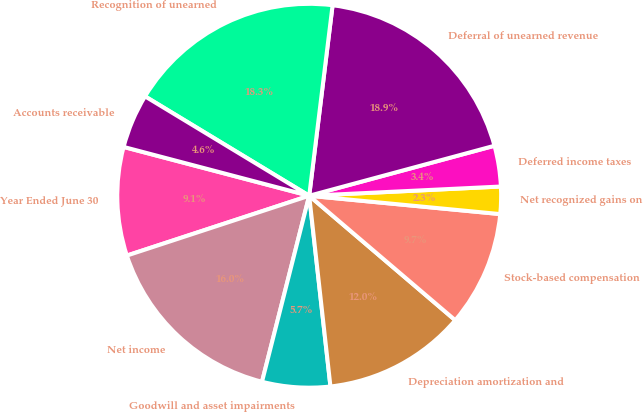Convert chart. <chart><loc_0><loc_0><loc_500><loc_500><pie_chart><fcel>Year Ended June 30<fcel>Net income<fcel>Goodwill and asset impairments<fcel>Depreciation amortization and<fcel>Stock-based compensation<fcel>Net recognized gains on<fcel>Deferred income taxes<fcel>Deferral of unearned revenue<fcel>Recognition of unearned<fcel>Accounts receivable<nl><fcel>9.14%<fcel>16.0%<fcel>5.72%<fcel>12.0%<fcel>9.71%<fcel>2.29%<fcel>3.43%<fcel>18.86%<fcel>18.28%<fcel>4.57%<nl></chart> 